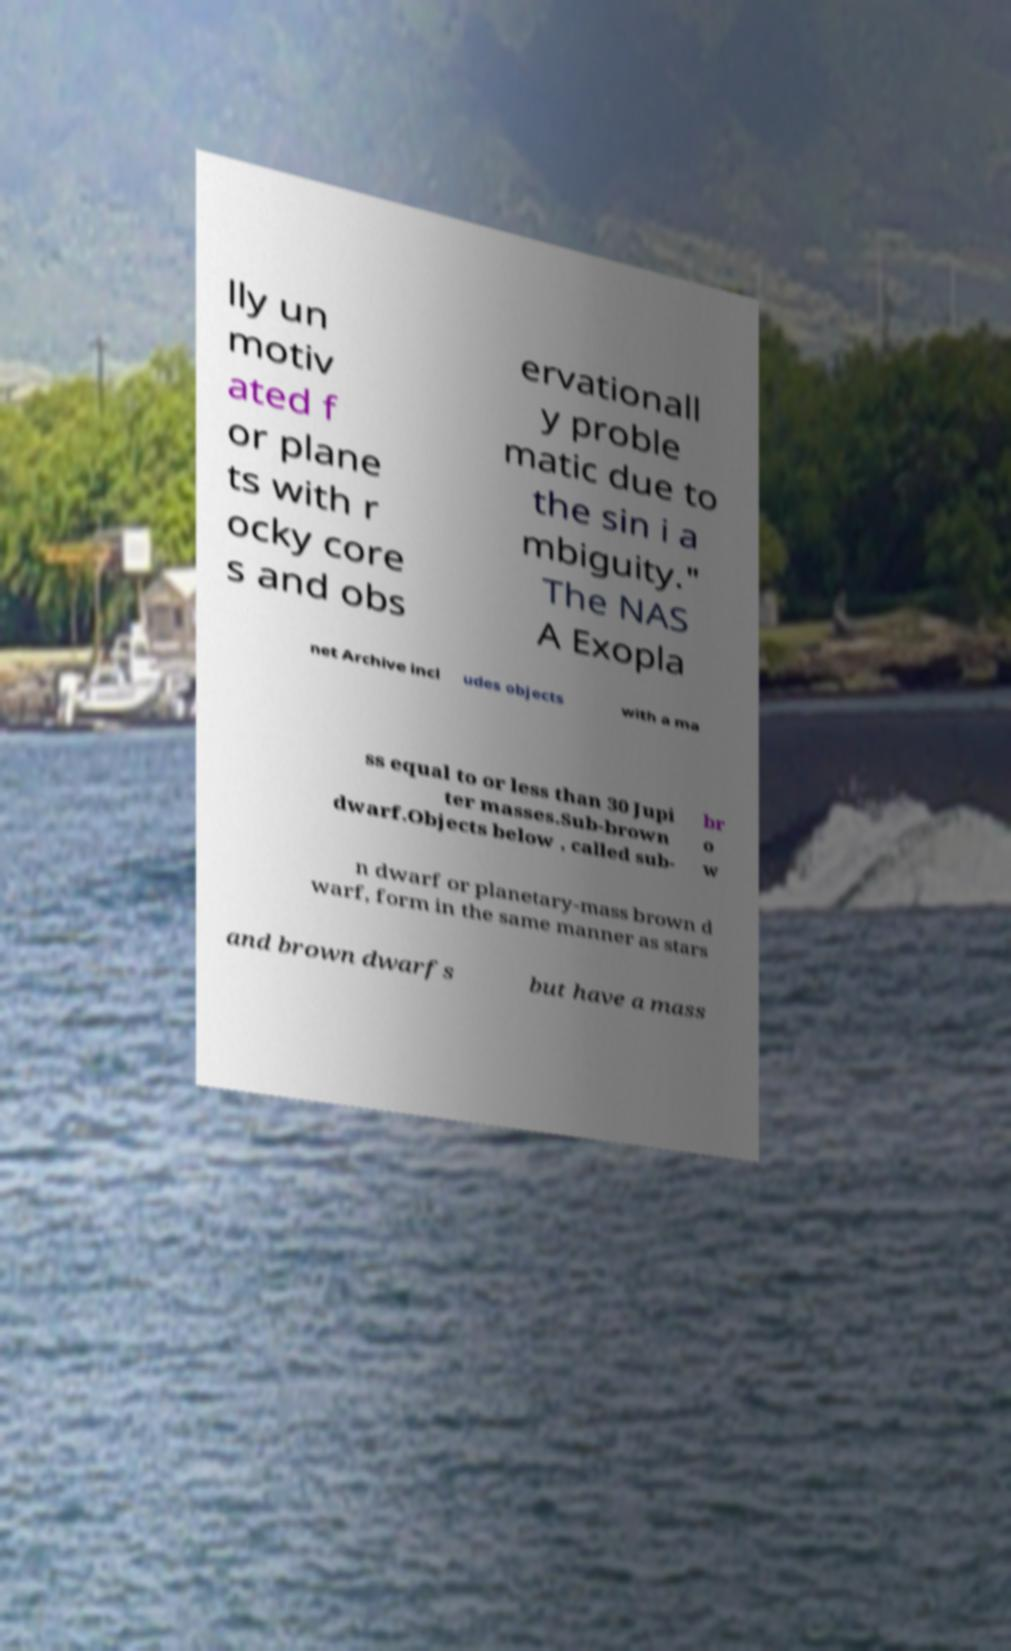For documentation purposes, I need the text within this image transcribed. Could you provide that? lly un motiv ated f or plane ts with r ocky core s and obs ervationall y proble matic due to the sin i a mbiguity." The NAS A Exopla net Archive incl udes objects with a ma ss equal to or less than 30 Jupi ter masses.Sub-brown dwarf.Objects below , called sub- br o w n dwarf or planetary-mass brown d warf, form in the same manner as stars and brown dwarfs but have a mass 